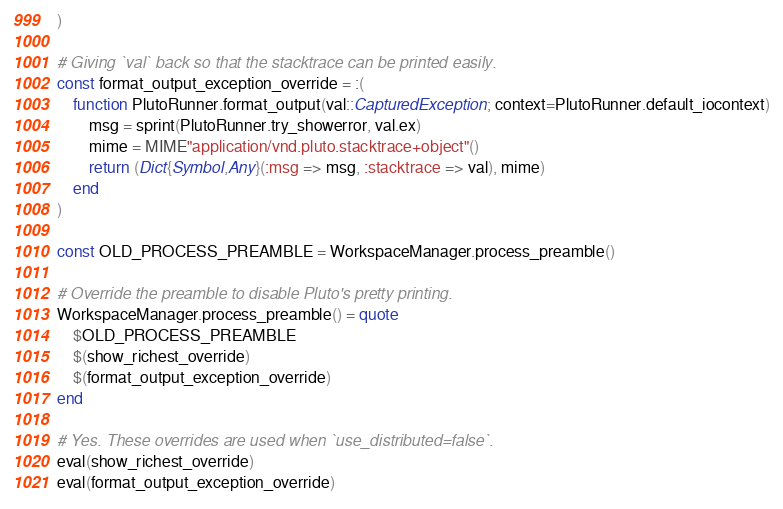Convert code to text. <code><loc_0><loc_0><loc_500><loc_500><_Julia_>)

# Giving `val` back so that the stacktrace can be printed easily.
const format_output_exception_override = :(
    function PlutoRunner.format_output(val::CapturedException; context=PlutoRunner.default_iocontext)
        msg = sprint(PlutoRunner.try_showerror, val.ex)
        mime = MIME"application/vnd.pluto.stacktrace+object"()
        return (Dict{Symbol,Any}(:msg => msg, :stacktrace => val), mime)
    end
)

const OLD_PROCESS_PREAMBLE = WorkspaceManager.process_preamble()

# Override the preamble to disable Pluto's pretty printing.
WorkspaceManager.process_preamble() = quote
    $OLD_PROCESS_PREAMBLE
    $(show_richest_override)
    $(format_output_exception_override)
end

# Yes. These overrides are used when `use_distributed=false`.
eval(show_richest_override)
eval(format_output_exception_override)

</code> 